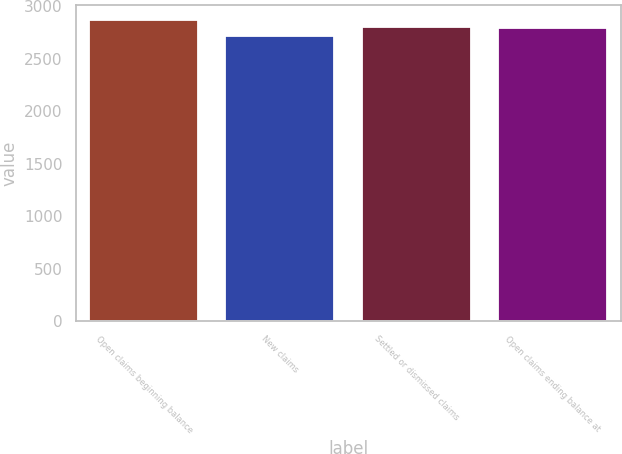Convert chart. <chart><loc_0><loc_0><loc_500><loc_500><bar_chart><fcel>Open claims beginning balance<fcel>New claims<fcel>Settled or dismissed claims<fcel>Open claims ending balance at<nl><fcel>2869<fcel>2719<fcel>2807<fcel>2792<nl></chart> 